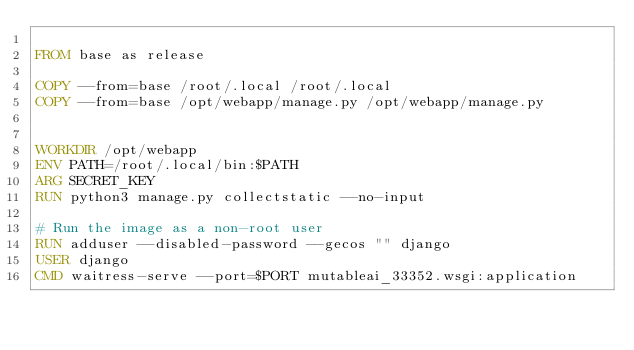<code> <loc_0><loc_0><loc_500><loc_500><_Dockerfile_>
FROM base as release

COPY --from=base /root/.local /root/.local
COPY --from=base /opt/webapp/manage.py /opt/webapp/manage.py


WORKDIR /opt/webapp
ENV PATH=/root/.local/bin:$PATH
ARG SECRET_KEY 
RUN python3 manage.py collectstatic --no-input

# Run the image as a non-root user
RUN adduser --disabled-password --gecos "" django
USER django
CMD waitress-serve --port=$PORT mutableai_33352.wsgi:application
</code> 